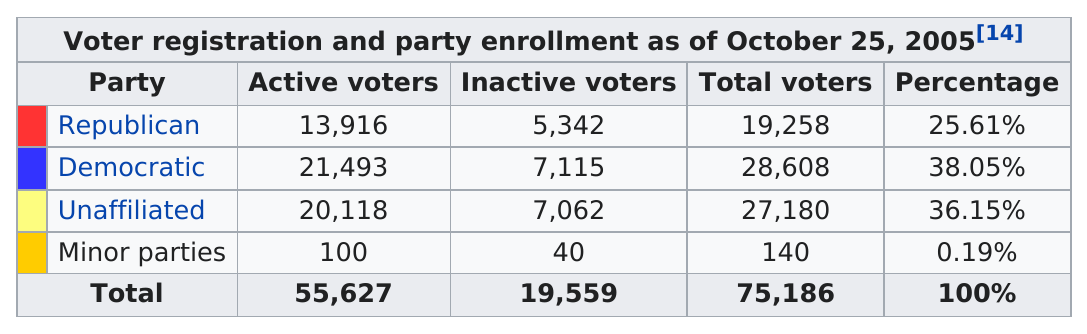Outline some significant characteristics in this image. On October 25, 2005, there were 55,627 active voters who were registered. As of October 25, 2005, the Democratic party had 7,115 inactive voters. 